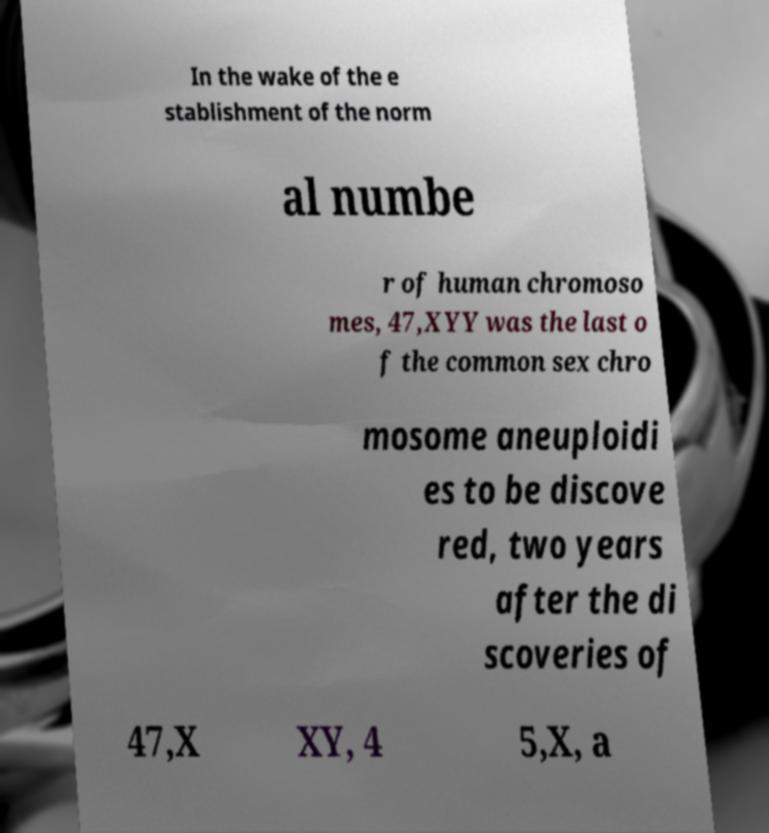What messages or text are displayed in this image? I need them in a readable, typed format. In the wake of the e stablishment of the norm al numbe r of human chromoso mes, 47,XYY was the last o f the common sex chro mosome aneuploidi es to be discove red, two years after the di scoveries of 47,X XY, 4 5,X, a 